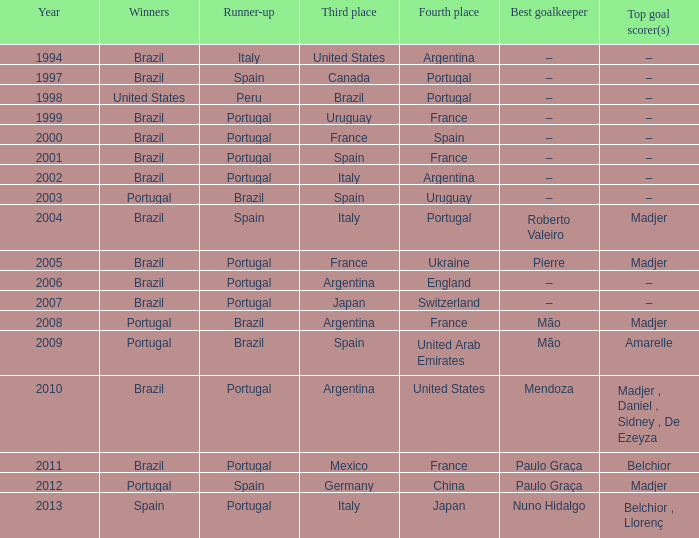Who were the winners in 1998? United States. 